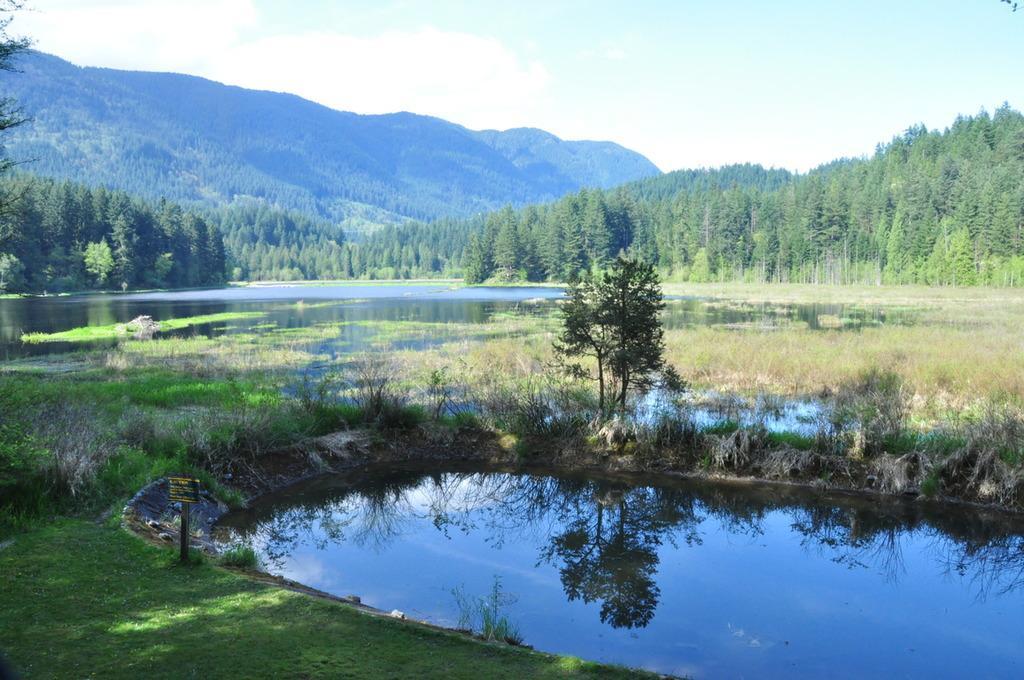In one or two sentences, can you explain what this image depicts? In this image there is water. Also there are plants and grass. There is a tree. In the background there are trees, hills and sky. 